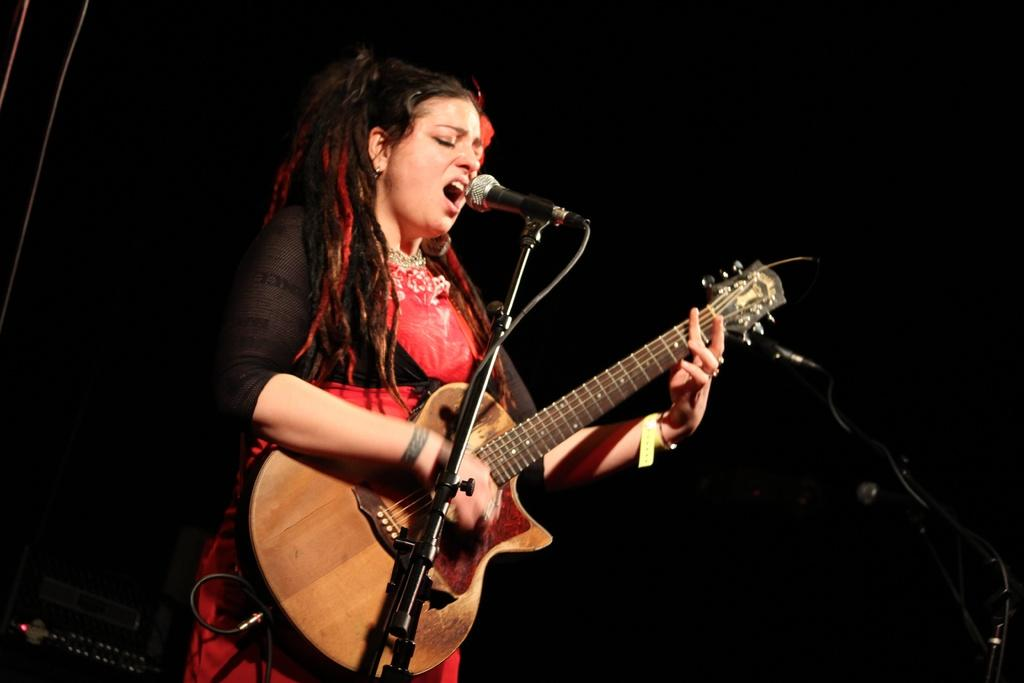Who is the main subject in the image? There is a woman in the image. What is the woman doing in the image? The woman is playing a guitar and singing a song. What object is in front of the woman? There is a microphone in front of the woman. What type of lead is the woman holding in the image? There is no lead visible in the image; the woman is holding a guitar. Can you see any farmers or playgrounds in the image? No, there are no farmers or playgrounds present in the image. 